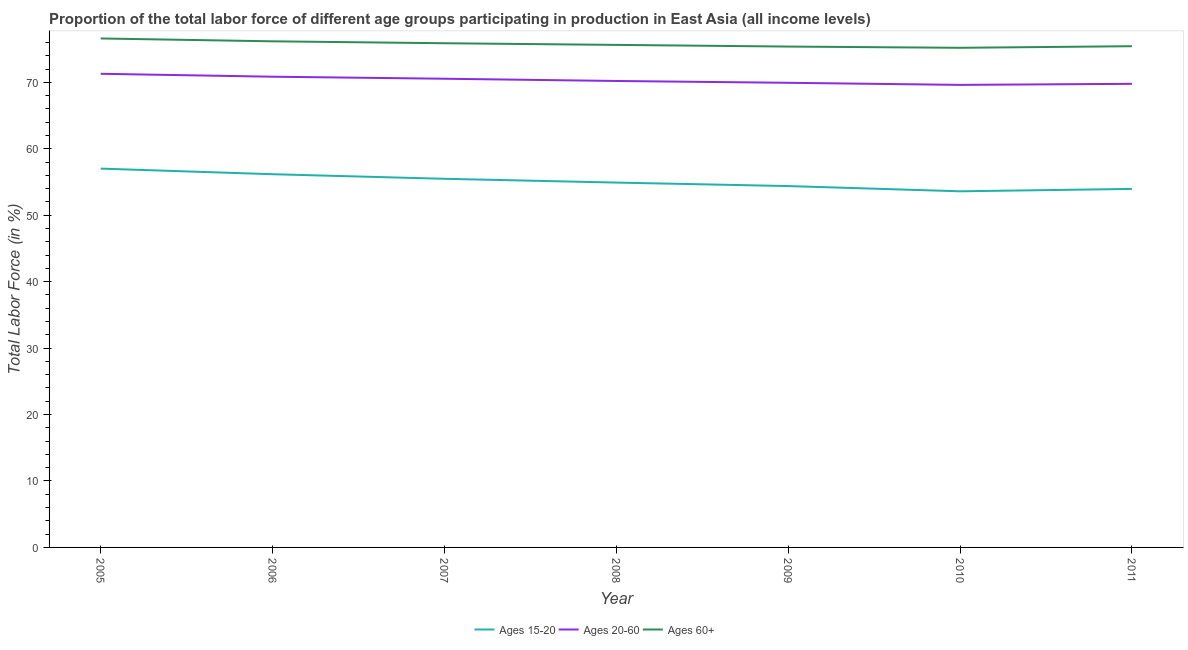What is the percentage of labor force within the age group 20-60 in 2008?
Offer a very short reply. 70.2. Across all years, what is the maximum percentage of labor force above age 60?
Keep it short and to the point. 76.6. Across all years, what is the minimum percentage of labor force above age 60?
Ensure brevity in your answer.  75.19. In which year was the percentage of labor force above age 60 minimum?
Keep it short and to the point. 2010. What is the total percentage of labor force above age 60 in the graph?
Ensure brevity in your answer.  530.27. What is the difference between the percentage of labor force within the age group 20-60 in 2009 and that in 2011?
Provide a short and direct response. 0.15. What is the difference between the percentage of labor force within the age group 20-60 in 2007 and the percentage of labor force above age 60 in 2010?
Offer a very short reply. -4.66. What is the average percentage of labor force within the age group 15-20 per year?
Give a very brief answer. 55.07. In the year 2011, what is the difference between the percentage of labor force within the age group 20-60 and percentage of labor force above age 60?
Offer a very short reply. -5.66. In how many years, is the percentage of labor force within the age group 20-60 greater than 12 %?
Provide a succinct answer. 7. What is the ratio of the percentage of labor force within the age group 20-60 in 2007 to that in 2008?
Make the answer very short. 1. Is the difference between the percentage of labor force within the age group 20-60 in 2008 and 2011 greater than the difference between the percentage of labor force within the age group 15-20 in 2008 and 2011?
Your response must be concise. No. What is the difference between the highest and the second highest percentage of labor force within the age group 15-20?
Make the answer very short. 0.84. What is the difference between the highest and the lowest percentage of labor force within the age group 20-60?
Ensure brevity in your answer.  1.67. Is the sum of the percentage of labor force within the age group 15-20 in 2005 and 2008 greater than the maximum percentage of labor force within the age group 20-60 across all years?
Ensure brevity in your answer.  Yes. Is the percentage of labor force within the age group 20-60 strictly greater than the percentage of labor force above age 60 over the years?
Offer a terse response. No. How many lines are there?
Keep it short and to the point. 3. Are the values on the major ticks of Y-axis written in scientific E-notation?
Offer a terse response. No. Does the graph contain any zero values?
Make the answer very short. No. Where does the legend appear in the graph?
Provide a succinct answer. Bottom center. How many legend labels are there?
Keep it short and to the point. 3. How are the legend labels stacked?
Your response must be concise. Horizontal. What is the title of the graph?
Your answer should be compact. Proportion of the total labor force of different age groups participating in production in East Asia (all income levels). Does "Taxes on income" appear as one of the legend labels in the graph?
Make the answer very short. No. What is the label or title of the X-axis?
Offer a terse response. Year. What is the label or title of the Y-axis?
Your response must be concise. Total Labor Force (in %). What is the Total Labor Force (in %) of Ages 15-20 in 2005?
Offer a terse response. 57.01. What is the Total Labor Force (in %) in Ages 20-60 in 2005?
Make the answer very short. 71.28. What is the Total Labor Force (in %) of Ages 60+ in 2005?
Give a very brief answer. 76.6. What is the Total Labor Force (in %) in Ages 15-20 in 2006?
Offer a very short reply. 56.16. What is the Total Labor Force (in %) in Ages 20-60 in 2006?
Your response must be concise. 70.84. What is the Total Labor Force (in %) in Ages 60+ in 2006?
Your answer should be compact. 76.17. What is the Total Labor Force (in %) of Ages 15-20 in 2007?
Your response must be concise. 55.48. What is the Total Labor Force (in %) of Ages 20-60 in 2007?
Your answer should be compact. 70.53. What is the Total Labor Force (in %) of Ages 60+ in 2007?
Provide a succinct answer. 75.88. What is the Total Labor Force (in %) of Ages 15-20 in 2008?
Your response must be concise. 54.91. What is the Total Labor Force (in %) in Ages 20-60 in 2008?
Ensure brevity in your answer.  70.2. What is the Total Labor Force (in %) in Ages 60+ in 2008?
Your response must be concise. 75.63. What is the Total Labor Force (in %) of Ages 15-20 in 2009?
Ensure brevity in your answer.  54.38. What is the Total Labor Force (in %) in Ages 20-60 in 2009?
Offer a terse response. 69.92. What is the Total Labor Force (in %) of Ages 60+ in 2009?
Your response must be concise. 75.38. What is the Total Labor Force (in %) in Ages 15-20 in 2010?
Offer a terse response. 53.59. What is the Total Labor Force (in %) in Ages 20-60 in 2010?
Keep it short and to the point. 69.61. What is the Total Labor Force (in %) in Ages 60+ in 2010?
Your response must be concise. 75.19. What is the Total Labor Force (in %) of Ages 15-20 in 2011?
Offer a very short reply. 53.95. What is the Total Labor Force (in %) of Ages 20-60 in 2011?
Ensure brevity in your answer.  69.77. What is the Total Labor Force (in %) in Ages 60+ in 2011?
Provide a short and direct response. 75.43. Across all years, what is the maximum Total Labor Force (in %) in Ages 15-20?
Provide a short and direct response. 57.01. Across all years, what is the maximum Total Labor Force (in %) in Ages 20-60?
Your answer should be very brief. 71.28. Across all years, what is the maximum Total Labor Force (in %) in Ages 60+?
Give a very brief answer. 76.6. Across all years, what is the minimum Total Labor Force (in %) in Ages 15-20?
Offer a terse response. 53.59. Across all years, what is the minimum Total Labor Force (in %) in Ages 20-60?
Give a very brief answer. 69.61. Across all years, what is the minimum Total Labor Force (in %) of Ages 60+?
Offer a very short reply. 75.19. What is the total Total Labor Force (in %) of Ages 15-20 in the graph?
Ensure brevity in your answer.  385.49. What is the total Total Labor Force (in %) in Ages 20-60 in the graph?
Provide a short and direct response. 492.16. What is the total Total Labor Force (in %) of Ages 60+ in the graph?
Your response must be concise. 530.27. What is the difference between the Total Labor Force (in %) in Ages 15-20 in 2005 and that in 2006?
Your answer should be very brief. 0.84. What is the difference between the Total Labor Force (in %) in Ages 20-60 in 2005 and that in 2006?
Provide a succinct answer. 0.44. What is the difference between the Total Labor Force (in %) of Ages 60+ in 2005 and that in 2006?
Keep it short and to the point. 0.43. What is the difference between the Total Labor Force (in %) in Ages 15-20 in 2005 and that in 2007?
Give a very brief answer. 1.53. What is the difference between the Total Labor Force (in %) of Ages 20-60 in 2005 and that in 2007?
Offer a very short reply. 0.75. What is the difference between the Total Labor Force (in %) in Ages 60+ in 2005 and that in 2007?
Make the answer very short. 0.72. What is the difference between the Total Labor Force (in %) of Ages 15-20 in 2005 and that in 2008?
Give a very brief answer. 2.1. What is the difference between the Total Labor Force (in %) in Ages 20-60 in 2005 and that in 2008?
Provide a short and direct response. 1.08. What is the difference between the Total Labor Force (in %) of Ages 60+ in 2005 and that in 2008?
Provide a short and direct response. 0.97. What is the difference between the Total Labor Force (in %) of Ages 15-20 in 2005 and that in 2009?
Make the answer very short. 2.63. What is the difference between the Total Labor Force (in %) of Ages 20-60 in 2005 and that in 2009?
Provide a short and direct response. 1.36. What is the difference between the Total Labor Force (in %) of Ages 60+ in 2005 and that in 2009?
Offer a terse response. 1.22. What is the difference between the Total Labor Force (in %) of Ages 15-20 in 2005 and that in 2010?
Provide a succinct answer. 3.42. What is the difference between the Total Labor Force (in %) of Ages 20-60 in 2005 and that in 2010?
Your answer should be compact. 1.67. What is the difference between the Total Labor Force (in %) in Ages 60+ in 2005 and that in 2010?
Offer a terse response. 1.4. What is the difference between the Total Labor Force (in %) of Ages 15-20 in 2005 and that in 2011?
Your response must be concise. 3.06. What is the difference between the Total Labor Force (in %) in Ages 20-60 in 2005 and that in 2011?
Provide a succinct answer. 1.51. What is the difference between the Total Labor Force (in %) in Ages 60+ in 2005 and that in 2011?
Make the answer very short. 1.16. What is the difference between the Total Labor Force (in %) in Ages 15-20 in 2006 and that in 2007?
Give a very brief answer. 0.69. What is the difference between the Total Labor Force (in %) of Ages 20-60 in 2006 and that in 2007?
Keep it short and to the point. 0.31. What is the difference between the Total Labor Force (in %) in Ages 60+ in 2006 and that in 2007?
Offer a very short reply. 0.29. What is the difference between the Total Labor Force (in %) of Ages 15-20 in 2006 and that in 2008?
Provide a succinct answer. 1.26. What is the difference between the Total Labor Force (in %) in Ages 20-60 in 2006 and that in 2008?
Your response must be concise. 0.64. What is the difference between the Total Labor Force (in %) of Ages 60+ in 2006 and that in 2008?
Offer a terse response. 0.54. What is the difference between the Total Labor Force (in %) in Ages 15-20 in 2006 and that in 2009?
Ensure brevity in your answer.  1.78. What is the difference between the Total Labor Force (in %) of Ages 20-60 in 2006 and that in 2009?
Your response must be concise. 0.92. What is the difference between the Total Labor Force (in %) of Ages 60+ in 2006 and that in 2009?
Provide a succinct answer. 0.79. What is the difference between the Total Labor Force (in %) in Ages 15-20 in 2006 and that in 2010?
Provide a succinct answer. 2.57. What is the difference between the Total Labor Force (in %) of Ages 20-60 in 2006 and that in 2010?
Provide a succinct answer. 1.23. What is the difference between the Total Labor Force (in %) of Ages 60+ in 2006 and that in 2010?
Your answer should be very brief. 0.98. What is the difference between the Total Labor Force (in %) of Ages 15-20 in 2006 and that in 2011?
Your answer should be very brief. 2.21. What is the difference between the Total Labor Force (in %) of Ages 20-60 in 2006 and that in 2011?
Give a very brief answer. 1.07. What is the difference between the Total Labor Force (in %) in Ages 60+ in 2006 and that in 2011?
Offer a very short reply. 0.74. What is the difference between the Total Labor Force (in %) of Ages 15-20 in 2007 and that in 2008?
Offer a very short reply. 0.57. What is the difference between the Total Labor Force (in %) of Ages 20-60 in 2007 and that in 2008?
Give a very brief answer. 0.33. What is the difference between the Total Labor Force (in %) of Ages 60+ in 2007 and that in 2008?
Ensure brevity in your answer.  0.25. What is the difference between the Total Labor Force (in %) in Ages 15-20 in 2007 and that in 2009?
Your answer should be compact. 1.1. What is the difference between the Total Labor Force (in %) of Ages 20-60 in 2007 and that in 2009?
Give a very brief answer. 0.61. What is the difference between the Total Labor Force (in %) in Ages 60+ in 2007 and that in 2009?
Offer a terse response. 0.5. What is the difference between the Total Labor Force (in %) in Ages 15-20 in 2007 and that in 2010?
Provide a succinct answer. 1.88. What is the difference between the Total Labor Force (in %) in Ages 20-60 in 2007 and that in 2010?
Ensure brevity in your answer.  0.92. What is the difference between the Total Labor Force (in %) of Ages 60+ in 2007 and that in 2010?
Your answer should be very brief. 0.69. What is the difference between the Total Labor Force (in %) in Ages 15-20 in 2007 and that in 2011?
Your answer should be very brief. 1.52. What is the difference between the Total Labor Force (in %) of Ages 20-60 in 2007 and that in 2011?
Give a very brief answer. 0.76. What is the difference between the Total Labor Force (in %) in Ages 60+ in 2007 and that in 2011?
Offer a very short reply. 0.45. What is the difference between the Total Labor Force (in %) of Ages 15-20 in 2008 and that in 2009?
Your response must be concise. 0.53. What is the difference between the Total Labor Force (in %) in Ages 20-60 in 2008 and that in 2009?
Your answer should be very brief. 0.28. What is the difference between the Total Labor Force (in %) of Ages 60+ in 2008 and that in 2009?
Your answer should be very brief. 0.25. What is the difference between the Total Labor Force (in %) of Ages 15-20 in 2008 and that in 2010?
Give a very brief answer. 1.31. What is the difference between the Total Labor Force (in %) in Ages 20-60 in 2008 and that in 2010?
Your response must be concise. 0.59. What is the difference between the Total Labor Force (in %) in Ages 60+ in 2008 and that in 2010?
Provide a short and direct response. 0.44. What is the difference between the Total Labor Force (in %) in Ages 15-20 in 2008 and that in 2011?
Offer a very short reply. 0.95. What is the difference between the Total Labor Force (in %) of Ages 20-60 in 2008 and that in 2011?
Your answer should be compact. 0.43. What is the difference between the Total Labor Force (in %) of Ages 60+ in 2008 and that in 2011?
Make the answer very short. 0.2. What is the difference between the Total Labor Force (in %) in Ages 15-20 in 2009 and that in 2010?
Keep it short and to the point. 0.79. What is the difference between the Total Labor Force (in %) in Ages 20-60 in 2009 and that in 2010?
Offer a terse response. 0.31. What is the difference between the Total Labor Force (in %) in Ages 60+ in 2009 and that in 2010?
Make the answer very short. 0.19. What is the difference between the Total Labor Force (in %) in Ages 15-20 in 2009 and that in 2011?
Keep it short and to the point. 0.43. What is the difference between the Total Labor Force (in %) of Ages 20-60 in 2009 and that in 2011?
Your answer should be very brief. 0.15. What is the difference between the Total Labor Force (in %) in Ages 60+ in 2009 and that in 2011?
Your answer should be compact. -0.06. What is the difference between the Total Labor Force (in %) of Ages 15-20 in 2010 and that in 2011?
Your response must be concise. -0.36. What is the difference between the Total Labor Force (in %) in Ages 20-60 in 2010 and that in 2011?
Make the answer very short. -0.16. What is the difference between the Total Labor Force (in %) of Ages 60+ in 2010 and that in 2011?
Give a very brief answer. -0.24. What is the difference between the Total Labor Force (in %) in Ages 15-20 in 2005 and the Total Labor Force (in %) in Ages 20-60 in 2006?
Your answer should be very brief. -13.83. What is the difference between the Total Labor Force (in %) in Ages 15-20 in 2005 and the Total Labor Force (in %) in Ages 60+ in 2006?
Provide a succinct answer. -19.16. What is the difference between the Total Labor Force (in %) of Ages 20-60 in 2005 and the Total Labor Force (in %) of Ages 60+ in 2006?
Your answer should be very brief. -4.89. What is the difference between the Total Labor Force (in %) of Ages 15-20 in 2005 and the Total Labor Force (in %) of Ages 20-60 in 2007?
Give a very brief answer. -13.53. What is the difference between the Total Labor Force (in %) in Ages 15-20 in 2005 and the Total Labor Force (in %) in Ages 60+ in 2007?
Give a very brief answer. -18.87. What is the difference between the Total Labor Force (in %) in Ages 20-60 in 2005 and the Total Labor Force (in %) in Ages 60+ in 2007?
Provide a succinct answer. -4.6. What is the difference between the Total Labor Force (in %) of Ages 15-20 in 2005 and the Total Labor Force (in %) of Ages 20-60 in 2008?
Make the answer very short. -13.19. What is the difference between the Total Labor Force (in %) of Ages 15-20 in 2005 and the Total Labor Force (in %) of Ages 60+ in 2008?
Ensure brevity in your answer.  -18.62. What is the difference between the Total Labor Force (in %) of Ages 20-60 in 2005 and the Total Labor Force (in %) of Ages 60+ in 2008?
Your response must be concise. -4.35. What is the difference between the Total Labor Force (in %) in Ages 15-20 in 2005 and the Total Labor Force (in %) in Ages 20-60 in 2009?
Provide a short and direct response. -12.91. What is the difference between the Total Labor Force (in %) in Ages 15-20 in 2005 and the Total Labor Force (in %) in Ages 60+ in 2009?
Provide a short and direct response. -18.37. What is the difference between the Total Labor Force (in %) in Ages 20-60 in 2005 and the Total Labor Force (in %) in Ages 60+ in 2009?
Give a very brief answer. -4.09. What is the difference between the Total Labor Force (in %) in Ages 15-20 in 2005 and the Total Labor Force (in %) in Ages 20-60 in 2010?
Your answer should be compact. -12.6. What is the difference between the Total Labor Force (in %) in Ages 15-20 in 2005 and the Total Labor Force (in %) in Ages 60+ in 2010?
Your answer should be compact. -18.18. What is the difference between the Total Labor Force (in %) of Ages 20-60 in 2005 and the Total Labor Force (in %) of Ages 60+ in 2010?
Provide a succinct answer. -3.91. What is the difference between the Total Labor Force (in %) in Ages 15-20 in 2005 and the Total Labor Force (in %) in Ages 20-60 in 2011?
Your answer should be very brief. -12.76. What is the difference between the Total Labor Force (in %) in Ages 15-20 in 2005 and the Total Labor Force (in %) in Ages 60+ in 2011?
Offer a terse response. -18.42. What is the difference between the Total Labor Force (in %) of Ages 20-60 in 2005 and the Total Labor Force (in %) of Ages 60+ in 2011?
Provide a succinct answer. -4.15. What is the difference between the Total Labor Force (in %) of Ages 15-20 in 2006 and the Total Labor Force (in %) of Ages 20-60 in 2007?
Provide a short and direct response. -14.37. What is the difference between the Total Labor Force (in %) of Ages 15-20 in 2006 and the Total Labor Force (in %) of Ages 60+ in 2007?
Your response must be concise. -19.71. What is the difference between the Total Labor Force (in %) of Ages 20-60 in 2006 and the Total Labor Force (in %) of Ages 60+ in 2007?
Give a very brief answer. -5.04. What is the difference between the Total Labor Force (in %) in Ages 15-20 in 2006 and the Total Labor Force (in %) in Ages 20-60 in 2008?
Offer a terse response. -14.04. What is the difference between the Total Labor Force (in %) of Ages 15-20 in 2006 and the Total Labor Force (in %) of Ages 60+ in 2008?
Keep it short and to the point. -19.46. What is the difference between the Total Labor Force (in %) in Ages 20-60 in 2006 and the Total Labor Force (in %) in Ages 60+ in 2008?
Offer a terse response. -4.79. What is the difference between the Total Labor Force (in %) in Ages 15-20 in 2006 and the Total Labor Force (in %) in Ages 20-60 in 2009?
Ensure brevity in your answer.  -13.76. What is the difference between the Total Labor Force (in %) of Ages 15-20 in 2006 and the Total Labor Force (in %) of Ages 60+ in 2009?
Give a very brief answer. -19.21. What is the difference between the Total Labor Force (in %) in Ages 20-60 in 2006 and the Total Labor Force (in %) in Ages 60+ in 2009?
Provide a short and direct response. -4.53. What is the difference between the Total Labor Force (in %) in Ages 15-20 in 2006 and the Total Labor Force (in %) in Ages 20-60 in 2010?
Make the answer very short. -13.45. What is the difference between the Total Labor Force (in %) of Ages 15-20 in 2006 and the Total Labor Force (in %) of Ages 60+ in 2010?
Make the answer very short. -19.03. What is the difference between the Total Labor Force (in %) of Ages 20-60 in 2006 and the Total Labor Force (in %) of Ages 60+ in 2010?
Provide a short and direct response. -4.35. What is the difference between the Total Labor Force (in %) of Ages 15-20 in 2006 and the Total Labor Force (in %) of Ages 20-60 in 2011?
Offer a terse response. -13.61. What is the difference between the Total Labor Force (in %) of Ages 15-20 in 2006 and the Total Labor Force (in %) of Ages 60+ in 2011?
Provide a succinct answer. -19.27. What is the difference between the Total Labor Force (in %) in Ages 20-60 in 2006 and the Total Labor Force (in %) in Ages 60+ in 2011?
Your answer should be compact. -4.59. What is the difference between the Total Labor Force (in %) of Ages 15-20 in 2007 and the Total Labor Force (in %) of Ages 20-60 in 2008?
Your response must be concise. -14.72. What is the difference between the Total Labor Force (in %) in Ages 15-20 in 2007 and the Total Labor Force (in %) in Ages 60+ in 2008?
Offer a terse response. -20.15. What is the difference between the Total Labor Force (in %) of Ages 20-60 in 2007 and the Total Labor Force (in %) of Ages 60+ in 2008?
Provide a succinct answer. -5.09. What is the difference between the Total Labor Force (in %) in Ages 15-20 in 2007 and the Total Labor Force (in %) in Ages 20-60 in 2009?
Make the answer very short. -14.45. What is the difference between the Total Labor Force (in %) of Ages 15-20 in 2007 and the Total Labor Force (in %) of Ages 60+ in 2009?
Your response must be concise. -19.9. What is the difference between the Total Labor Force (in %) in Ages 20-60 in 2007 and the Total Labor Force (in %) in Ages 60+ in 2009?
Offer a terse response. -4.84. What is the difference between the Total Labor Force (in %) in Ages 15-20 in 2007 and the Total Labor Force (in %) in Ages 20-60 in 2010?
Offer a terse response. -14.13. What is the difference between the Total Labor Force (in %) in Ages 15-20 in 2007 and the Total Labor Force (in %) in Ages 60+ in 2010?
Offer a terse response. -19.71. What is the difference between the Total Labor Force (in %) of Ages 20-60 in 2007 and the Total Labor Force (in %) of Ages 60+ in 2010?
Provide a short and direct response. -4.66. What is the difference between the Total Labor Force (in %) in Ages 15-20 in 2007 and the Total Labor Force (in %) in Ages 20-60 in 2011?
Make the answer very short. -14.29. What is the difference between the Total Labor Force (in %) in Ages 15-20 in 2007 and the Total Labor Force (in %) in Ages 60+ in 2011?
Offer a terse response. -19.95. What is the difference between the Total Labor Force (in %) of Ages 20-60 in 2007 and the Total Labor Force (in %) of Ages 60+ in 2011?
Ensure brevity in your answer.  -4.9. What is the difference between the Total Labor Force (in %) of Ages 15-20 in 2008 and the Total Labor Force (in %) of Ages 20-60 in 2009?
Offer a very short reply. -15.02. What is the difference between the Total Labor Force (in %) in Ages 15-20 in 2008 and the Total Labor Force (in %) in Ages 60+ in 2009?
Provide a succinct answer. -20.47. What is the difference between the Total Labor Force (in %) of Ages 20-60 in 2008 and the Total Labor Force (in %) of Ages 60+ in 2009?
Give a very brief answer. -5.18. What is the difference between the Total Labor Force (in %) of Ages 15-20 in 2008 and the Total Labor Force (in %) of Ages 20-60 in 2010?
Provide a short and direct response. -14.7. What is the difference between the Total Labor Force (in %) in Ages 15-20 in 2008 and the Total Labor Force (in %) in Ages 60+ in 2010?
Provide a short and direct response. -20.28. What is the difference between the Total Labor Force (in %) in Ages 20-60 in 2008 and the Total Labor Force (in %) in Ages 60+ in 2010?
Give a very brief answer. -4.99. What is the difference between the Total Labor Force (in %) of Ages 15-20 in 2008 and the Total Labor Force (in %) of Ages 20-60 in 2011?
Provide a succinct answer. -14.86. What is the difference between the Total Labor Force (in %) of Ages 15-20 in 2008 and the Total Labor Force (in %) of Ages 60+ in 2011?
Provide a succinct answer. -20.52. What is the difference between the Total Labor Force (in %) in Ages 20-60 in 2008 and the Total Labor Force (in %) in Ages 60+ in 2011?
Provide a succinct answer. -5.23. What is the difference between the Total Labor Force (in %) in Ages 15-20 in 2009 and the Total Labor Force (in %) in Ages 20-60 in 2010?
Your answer should be very brief. -15.23. What is the difference between the Total Labor Force (in %) of Ages 15-20 in 2009 and the Total Labor Force (in %) of Ages 60+ in 2010?
Give a very brief answer. -20.81. What is the difference between the Total Labor Force (in %) of Ages 20-60 in 2009 and the Total Labor Force (in %) of Ages 60+ in 2010?
Keep it short and to the point. -5.27. What is the difference between the Total Labor Force (in %) in Ages 15-20 in 2009 and the Total Labor Force (in %) in Ages 20-60 in 2011?
Keep it short and to the point. -15.39. What is the difference between the Total Labor Force (in %) of Ages 15-20 in 2009 and the Total Labor Force (in %) of Ages 60+ in 2011?
Make the answer very short. -21.05. What is the difference between the Total Labor Force (in %) of Ages 20-60 in 2009 and the Total Labor Force (in %) of Ages 60+ in 2011?
Offer a terse response. -5.51. What is the difference between the Total Labor Force (in %) in Ages 15-20 in 2010 and the Total Labor Force (in %) in Ages 20-60 in 2011?
Offer a very short reply. -16.18. What is the difference between the Total Labor Force (in %) of Ages 15-20 in 2010 and the Total Labor Force (in %) of Ages 60+ in 2011?
Offer a terse response. -21.84. What is the difference between the Total Labor Force (in %) of Ages 20-60 in 2010 and the Total Labor Force (in %) of Ages 60+ in 2011?
Give a very brief answer. -5.82. What is the average Total Labor Force (in %) of Ages 15-20 per year?
Offer a terse response. 55.07. What is the average Total Labor Force (in %) of Ages 20-60 per year?
Ensure brevity in your answer.  70.31. What is the average Total Labor Force (in %) in Ages 60+ per year?
Your answer should be compact. 75.75. In the year 2005, what is the difference between the Total Labor Force (in %) in Ages 15-20 and Total Labor Force (in %) in Ages 20-60?
Keep it short and to the point. -14.27. In the year 2005, what is the difference between the Total Labor Force (in %) in Ages 15-20 and Total Labor Force (in %) in Ages 60+?
Make the answer very short. -19.59. In the year 2005, what is the difference between the Total Labor Force (in %) in Ages 20-60 and Total Labor Force (in %) in Ages 60+?
Offer a terse response. -5.31. In the year 2006, what is the difference between the Total Labor Force (in %) in Ages 15-20 and Total Labor Force (in %) in Ages 20-60?
Ensure brevity in your answer.  -14.68. In the year 2006, what is the difference between the Total Labor Force (in %) of Ages 15-20 and Total Labor Force (in %) of Ages 60+?
Provide a succinct answer. -20. In the year 2006, what is the difference between the Total Labor Force (in %) in Ages 20-60 and Total Labor Force (in %) in Ages 60+?
Offer a terse response. -5.33. In the year 2007, what is the difference between the Total Labor Force (in %) in Ages 15-20 and Total Labor Force (in %) in Ages 20-60?
Keep it short and to the point. -15.06. In the year 2007, what is the difference between the Total Labor Force (in %) of Ages 15-20 and Total Labor Force (in %) of Ages 60+?
Your answer should be very brief. -20.4. In the year 2007, what is the difference between the Total Labor Force (in %) of Ages 20-60 and Total Labor Force (in %) of Ages 60+?
Offer a terse response. -5.34. In the year 2008, what is the difference between the Total Labor Force (in %) in Ages 15-20 and Total Labor Force (in %) in Ages 20-60?
Your response must be concise. -15.29. In the year 2008, what is the difference between the Total Labor Force (in %) in Ages 15-20 and Total Labor Force (in %) in Ages 60+?
Keep it short and to the point. -20.72. In the year 2008, what is the difference between the Total Labor Force (in %) of Ages 20-60 and Total Labor Force (in %) of Ages 60+?
Provide a short and direct response. -5.43. In the year 2009, what is the difference between the Total Labor Force (in %) of Ages 15-20 and Total Labor Force (in %) of Ages 20-60?
Provide a succinct answer. -15.54. In the year 2009, what is the difference between the Total Labor Force (in %) in Ages 15-20 and Total Labor Force (in %) in Ages 60+?
Ensure brevity in your answer.  -20.99. In the year 2009, what is the difference between the Total Labor Force (in %) of Ages 20-60 and Total Labor Force (in %) of Ages 60+?
Offer a terse response. -5.45. In the year 2010, what is the difference between the Total Labor Force (in %) of Ages 15-20 and Total Labor Force (in %) of Ages 20-60?
Ensure brevity in your answer.  -16.02. In the year 2010, what is the difference between the Total Labor Force (in %) of Ages 15-20 and Total Labor Force (in %) of Ages 60+?
Keep it short and to the point. -21.6. In the year 2010, what is the difference between the Total Labor Force (in %) of Ages 20-60 and Total Labor Force (in %) of Ages 60+?
Provide a short and direct response. -5.58. In the year 2011, what is the difference between the Total Labor Force (in %) in Ages 15-20 and Total Labor Force (in %) in Ages 20-60?
Offer a terse response. -15.82. In the year 2011, what is the difference between the Total Labor Force (in %) in Ages 15-20 and Total Labor Force (in %) in Ages 60+?
Your answer should be compact. -21.48. In the year 2011, what is the difference between the Total Labor Force (in %) of Ages 20-60 and Total Labor Force (in %) of Ages 60+?
Your response must be concise. -5.66. What is the ratio of the Total Labor Force (in %) of Ages 15-20 in 2005 to that in 2006?
Ensure brevity in your answer.  1.01. What is the ratio of the Total Labor Force (in %) in Ages 60+ in 2005 to that in 2006?
Offer a very short reply. 1.01. What is the ratio of the Total Labor Force (in %) in Ages 15-20 in 2005 to that in 2007?
Your response must be concise. 1.03. What is the ratio of the Total Labor Force (in %) in Ages 20-60 in 2005 to that in 2007?
Keep it short and to the point. 1.01. What is the ratio of the Total Labor Force (in %) in Ages 60+ in 2005 to that in 2007?
Offer a very short reply. 1.01. What is the ratio of the Total Labor Force (in %) in Ages 15-20 in 2005 to that in 2008?
Your answer should be compact. 1.04. What is the ratio of the Total Labor Force (in %) in Ages 20-60 in 2005 to that in 2008?
Offer a terse response. 1.02. What is the ratio of the Total Labor Force (in %) of Ages 60+ in 2005 to that in 2008?
Provide a short and direct response. 1.01. What is the ratio of the Total Labor Force (in %) in Ages 15-20 in 2005 to that in 2009?
Provide a short and direct response. 1.05. What is the ratio of the Total Labor Force (in %) in Ages 20-60 in 2005 to that in 2009?
Give a very brief answer. 1.02. What is the ratio of the Total Labor Force (in %) in Ages 60+ in 2005 to that in 2009?
Keep it short and to the point. 1.02. What is the ratio of the Total Labor Force (in %) in Ages 15-20 in 2005 to that in 2010?
Offer a very short reply. 1.06. What is the ratio of the Total Labor Force (in %) of Ages 60+ in 2005 to that in 2010?
Provide a succinct answer. 1.02. What is the ratio of the Total Labor Force (in %) in Ages 15-20 in 2005 to that in 2011?
Provide a short and direct response. 1.06. What is the ratio of the Total Labor Force (in %) of Ages 20-60 in 2005 to that in 2011?
Give a very brief answer. 1.02. What is the ratio of the Total Labor Force (in %) in Ages 60+ in 2005 to that in 2011?
Your answer should be compact. 1.02. What is the ratio of the Total Labor Force (in %) of Ages 15-20 in 2006 to that in 2007?
Offer a terse response. 1.01. What is the ratio of the Total Labor Force (in %) in Ages 60+ in 2006 to that in 2007?
Your answer should be very brief. 1. What is the ratio of the Total Labor Force (in %) of Ages 15-20 in 2006 to that in 2008?
Provide a succinct answer. 1.02. What is the ratio of the Total Labor Force (in %) in Ages 20-60 in 2006 to that in 2008?
Your response must be concise. 1.01. What is the ratio of the Total Labor Force (in %) of Ages 60+ in 2006 to that in 2008?
Provide a succinct answer. 1.01. What is the ratio of the Total Labor Force (in %) of Ages 15-20 in 2006 to that in 2009?
Keep it short and to the point. 1.03. What is the ratio of the Total Labor Force (in %) in Ages 20-60 in 2006 to that in 2009?
Provide a succinct answer. 1.01. What is the ratio of the Total Labor Force (in %) of Ages 60+ in 2006 to that in 2009?
Offer a terse response. 1.01. What is the ratio of the Total Labor Force (in %) in Ages 15-20 in 2006 to that in 2010?
Give a very brief answer. 1.05. What is the ratio of the Total Labor Force (in %) of Ages 20-60 in 2006 to that in 2010?
Keep it short and to the point. 1.02. What is the ratio of the Total Labor Force (in %) of Ages 15-20 in 2006 to that in 2011?
Provide a short and direct response. 1.04. What is the ratio of the Total Labor Force (in %) in Ages 20-60 in 2006 to that in 2011?
Your response must be concise. 1.02. What is the ratio of the Total Labor Force (in %) in Ages 60+ in 2006 to that in 2011?
Your answer should be compact. 1.01. What is the ratio of the Total Labor Force (in %) of Ages 15-20 in 2007 to that in 2008?
Offer a terse response. 1.01. What is the ratio of the Total Labor Force (in %) of Ages 60+ in 2007 to that in 2008?
Offer a very short reply. 1. What is the ratio of the Total Labor Force (in %) in Ages 15-20 in 2007 to that in 2009?
Provide a short and direct response. 1.02. What is the ratio of the Total Labor Force (in %) in Ages 20-60 in 2007 to that in 2009?
Offer a terse response. 1.01. What is the ratio of the Total Labor Force (in %) in Ages 15-20 in 2007 to that in 2010?
Offer a terse response. 1.04. What is the ratio of the Total Labor Force (in %) in Ages 20-60 in 2007 to that in 2010?
Make the answer very short. 1.01. What is the ratio of the Total Labor Force (in %) in Ages 60+ in 2007 to that in 2010?
Give a very brief answer. 1.01. What is the ratio of the Total Labor Force (in %) in Ages 15-20 in 2007 to that in 2011?
Give a very brief answer. 1.03. What is the ratio of the Total Labor Force (in %) of Ages 60+ in 2007 to that in 2011?
Offer a terse response. 1.01. What is the ratio of the Total Labor Force (in %) of Ages 15-20 in 2008 to that in 2009?
Provide a short and direct response. 1.01. What is the ratio of the Total Labor Force (in %) in Ages 15-20 in 2008 to that in 2010?
Your response must be concise. 1.02. What is the ratio of the Total Labor Force (in %) in Ages 20-60 in 2008 to that in 2010?
Give a very brief answer. 1.01. What is the ratio of the Total Labor Force (in %) of Ages 60+ in 2008 to that in 2010?
Give a very brief answer. 1.01. What is the ratio of the Total Labor Force (in %) in Ages 15-20 in 2008 to that in 2011?
Offer a terse response. 1.02. What is the ratio of the Total Labor Force (in %) of Ages 15-20 in 2009 to that in 2010?
Your response must be concise. 1.01. What is the ratio of the Total Labor Force (in %) in Ages 15-20 in 2009 to that in 2011?
Provide a short and direct response. 1.01. What is the ratio of the Total Labor Force (in %) of Ages 20-60 in 2009 to that in 2011?
Provide a succinct answer. 1. What is the ratio of the Total Labor Force (in %) in Ages 15-20 in 2010 to that in 2011?
Ensure brevity in your answer.  0.99. What is the ratio of the Total Labor Force (in %) of Ages 20-60 in 2010 to that in 2011?
Make the answer very short. 1. What is the ratio of the Total Labor Force (in %) of Ages 60+ in 2010 to that in 2011?
Provide a short and direct response. 1. What is the difference between the highest and the second highest Total Labor Force (in %) in Ages 15-20?
Give a very brief answer. 0.84. What is the difference between the highest and the second highest Total Labor Force (in %) in Ages 20-60?
Provide a succinct answer. 0.44. What is the difference between the highest and the second highest Total Labor Force (in %) of Ages 60+?
Provide a short and direct response. 0.43. What is the difference between the highest and the lowest Total Labor Force (in %) of Ages 15-20?
Your response must be concise. 3.42. What is the difference between the highest and the lowest Total Labor Force (in %) in Ages 20-60?
Ensure brevity in your answer.  1.67. What is the difference between the highest and the lowest Total Labor Force (in %) of Ages 60+?
Keep it short and to the point. 1.4. 